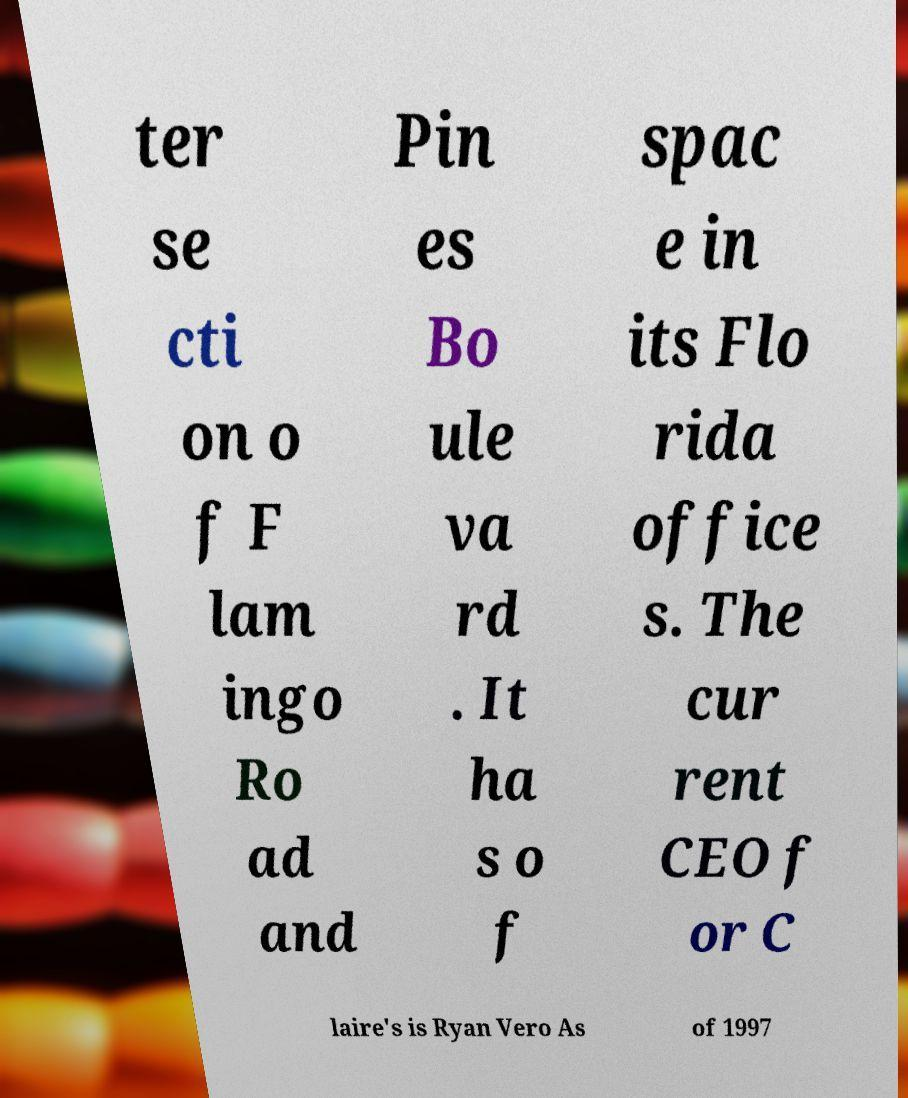Can you read and provide the text displayed in the image?This photo seems to have some interesting text. Can you extract and type it out for me? ter se cti on o f F lam ingo Ro ad and Pin es Bo ule va rd . It ha s o f spac e in its Flo rida office s. The cur rent CEO f or C laire's is Ryan Vero As of 1997 